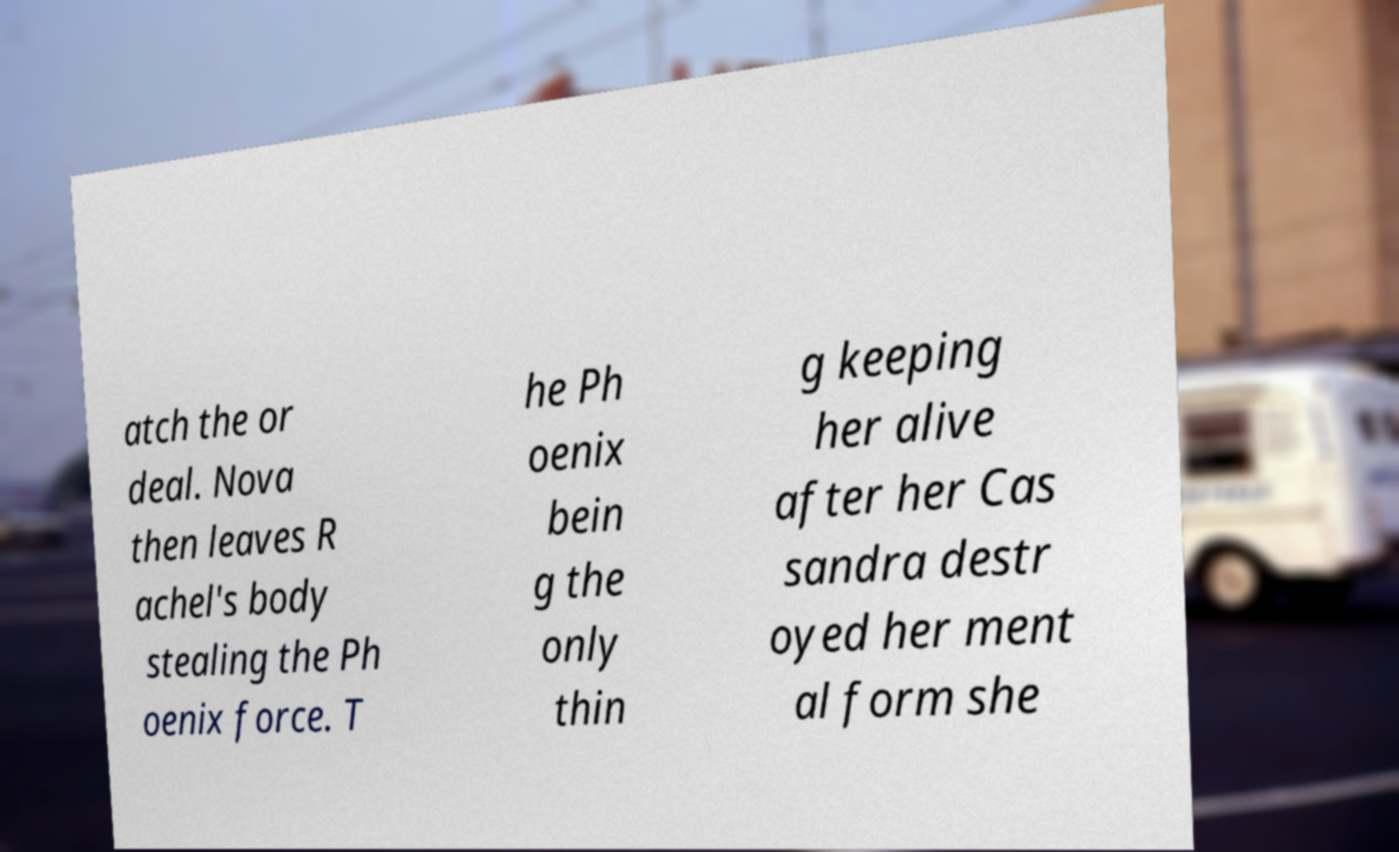Could you assist in decoding the text presented in this image and type it out clearly? atch the or deal. Nova then leaves R achel's body stealing the Ph oenix force. T he Ph oenix bein g the only thin g keeping her alive after her Cas sandra destr oyed her ment al form she 